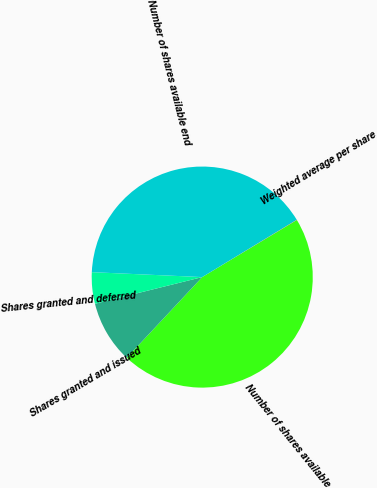<chart> <loc_0><loc_0><loc_500><loc_500><pie_chart><fcel>Number of shares available<fcel>Shares granted and issued<fcel>Shares granted and deferred<fcel>Number of shares available end<fcel>Weighted average per share<nl><fcel>45.61%<fcel>9.15%<fcel>4.59%<fcel>40.62%<fcel>0.03%<nl></chart> 